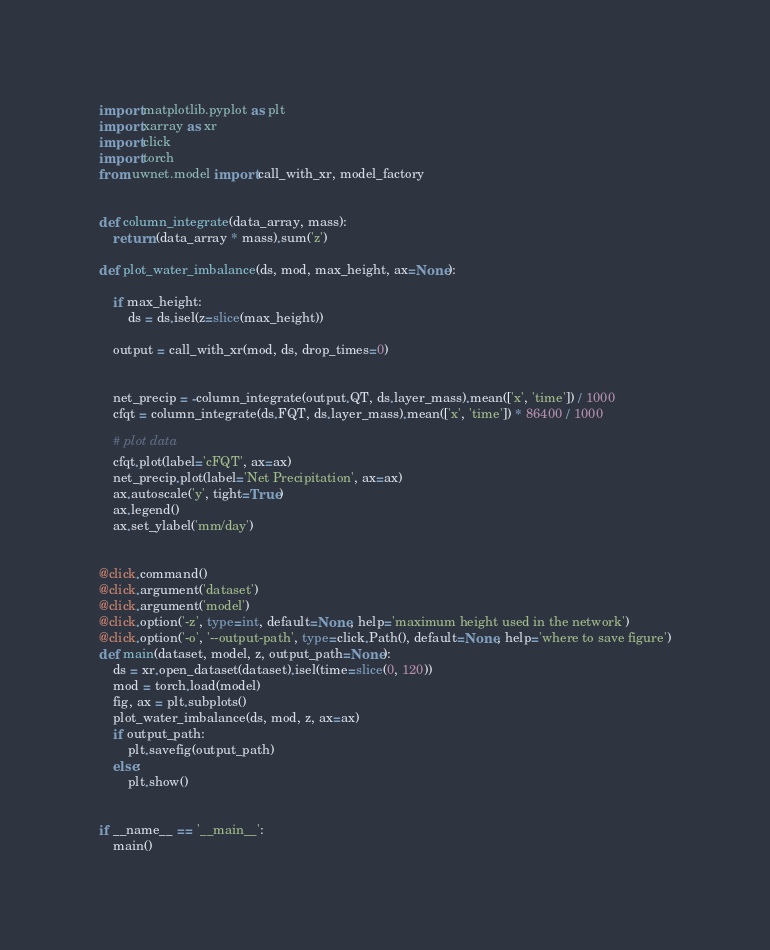<code> <loc_0><loc_0><loc_500><loc_500><_Python_>import matplotlib.pyplot as plt
import xarray as xr
import click
import torch
from uwnet.model import call_with_xr, model_factory


def column_integrate(data_array, mass):
    return (data_array * mass).sum('z')

def plot_water_imbalance(ds, mod, max_height, ax=None):

    if max_height:
        ds = ds.isel(z=slice(max_height))

    output = call_with_xr(mod, ds, drop_times=0)


    net_precip = -column_integrate(output.QT, ds.layer_mass).mean(['x', 'time']) / 1000
    cfqt = column_integrate(ds.FQT, ds.layer_mass).mean(['x', 'time']) * 86400 / 1000

    # plot data
    cfqt.plot(label='cFQT', ax=ax)
    net_precip.plot(label='Net Precipitation', ax=ax)
    ax.autoscale('y', tight=True)
    ax.legend()
    ax.set_ylabel('mm/day')


@click.command()
@click.argument('dataset')
@click.argument('model')
@click.option('-z', type=int, default=None, help='maximum height used in the network')
@click.option('-o', '--output-path', type=click.Path(), default=None, help='where to save figure')
def main(dataset, model, z, output_path=None):
    ds = xr.open_dataset(dataset).isel(time=slice(0, 120))
    mod = torch.load(model)
    fig, ax = plt.subplots()
    plot_water_imbalance(ds, mod, z, ax=ax)
    if output_path:
        plt.savefig(output_path)
    else:
        plt.show()


if __name__ == '__main__':
    main()
</code> 